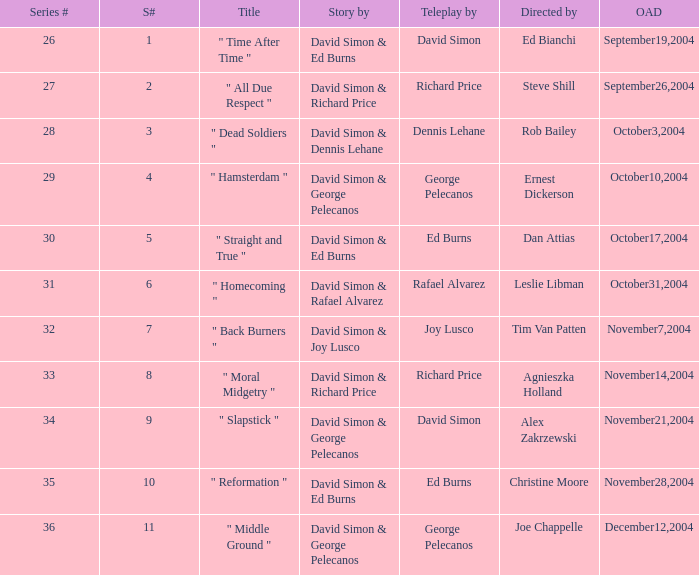Who is the teleplay by when the director is Rob Bailey? Dennis Lehane. I'm looking to parse the entire table for insights. Could you assist me with that? {'header': ['Series #', 'S#', 'Title', 'Story by', 'Teleplay by', 'Directed by', 'OAD'], 'rows': [['26', '1', '" Time After Time "', 'David Simon & Ed Burns', 'David Simon', 'Ed Bianchi', 'September19,2004'], ['27', '2', '" All Due Respect "', 'David Simon & Richard Price', 'Richard Price', 'Steve Shill', 'September26,2004'], ['28', '3', '" Dead Soldiers "', 'David Simon & Dennis Lehane', 'Dennis Lehane', 'Rob Bailey', 'October3,2004'], ['29', '4', '" Hamsterdam "', 'David Simon & George Pelecanos', 'George Pelecanos', 'Ernest Dickerson', 'October10,2004'], ['30', '5', '" Straight and True "', 'David Simon & Ed Burns', 'Ed Burns', 'Dan Attias', 'October17,2004'], ['31', '6', '" Homecoming "', 'David Simon & Rafael Alvarez', 'Rafael Alvarez', 'Leslie Libman', 'October31,2004'], ['32', '7', '" Back Burners "', 'David Simon & Joy Lusco', 'Joy Lusco', 'Tim Van Patten', 'November7,2004'], ['33', '8', '" Moral Midgetry "', 'David Simon & Richard Price', 'Richard Price', 'Agnieszka Holland', 'November14,2004'], ['34', '9', '" Slapstick "', 'David Simon & George Pelecanos', 'David Simon', 'Alex Zakrzewski', 'November21,2004'], ['35', '10', '" Reformation "', 'David Simon & Ed Burns', 'Ed Burns', 'Christine Moore', 'November28,2004'], ['36', '11', '" Middle Ground "', 'David Simon & George Pelecanos', 'George Pelecanos', 'Joe Chappelle', 'December12,2004']]} 